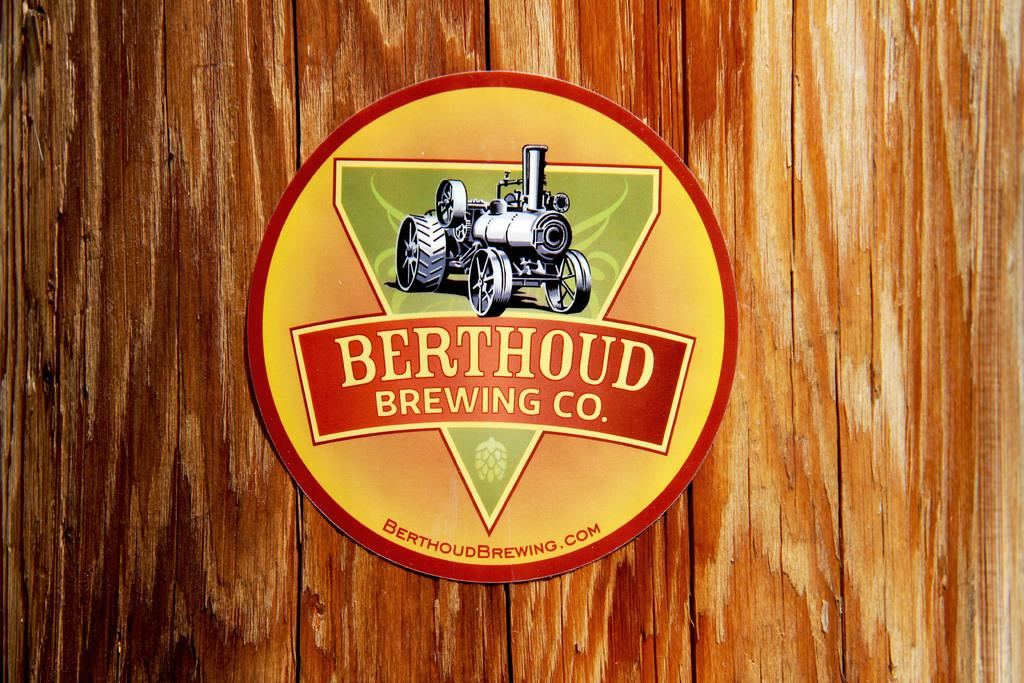What is featured on the poster in the image? The poster contains a vehicle. What type of background is present in the image? There is a wooden background in the image. Can you spot any mist in the image? There is no mist present in the image; the background is made of wood. 